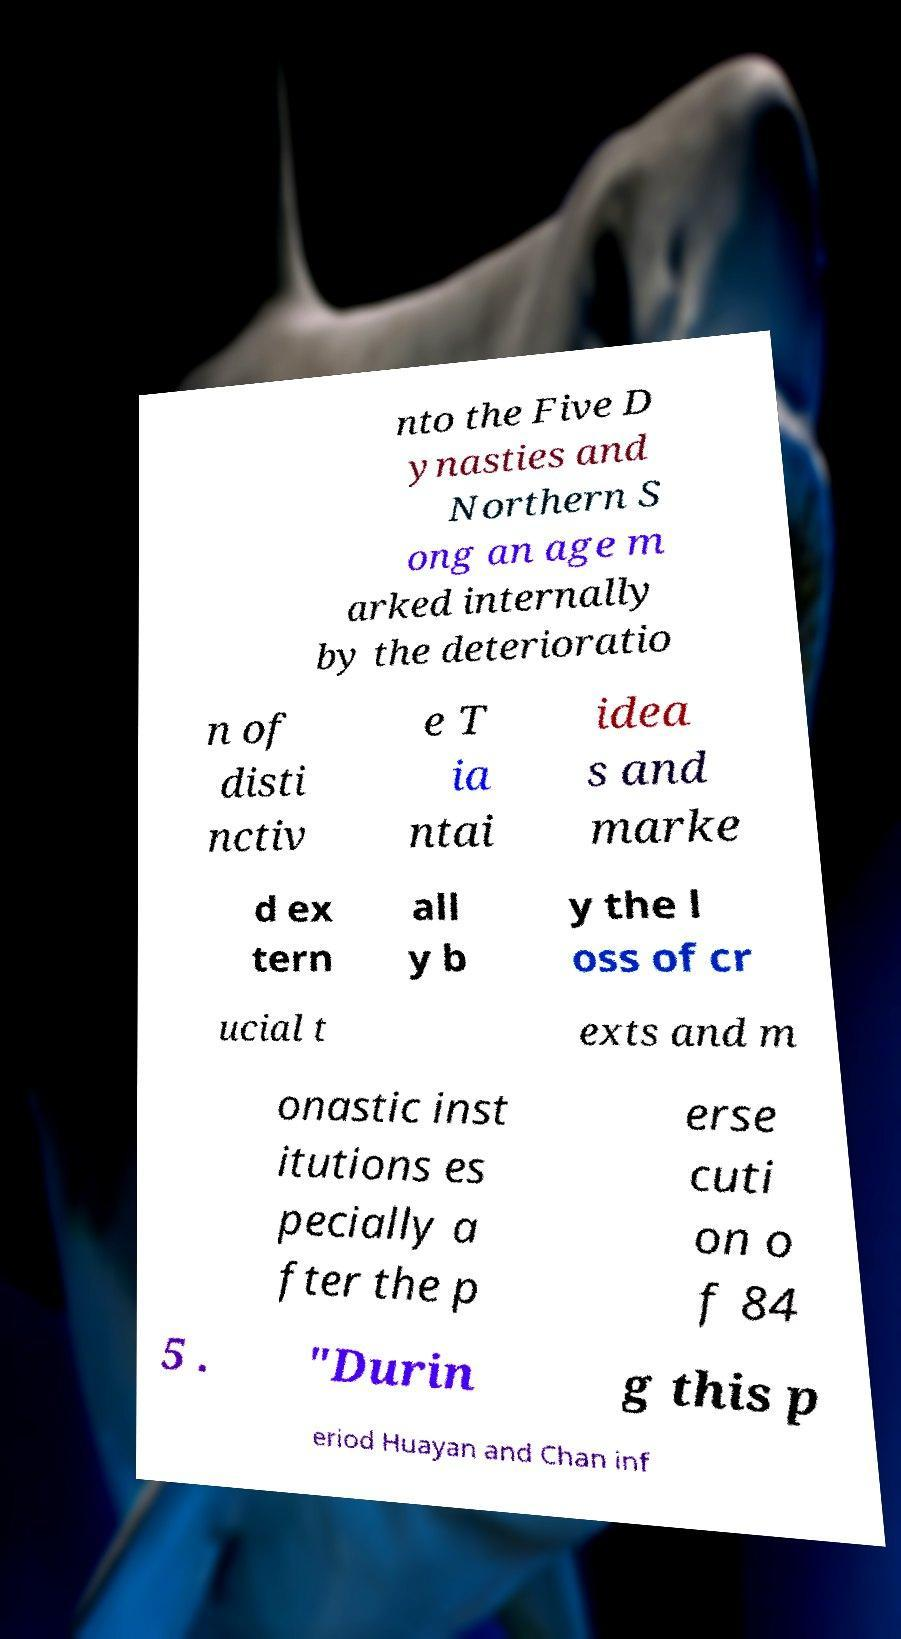Can you accurately transcribe the text from the provided image for me? nto the Five D ynasties and Northern S ong an age m arked internally by the deterioratio n of disti nctiv e T ia ntai idea s and marke d ex tern all y b y the l oss of cr ucial t exts and m onastic inst itutions es pecially a fter the p erse cuti on o f 84 5 . "Durin g this p eriod Huayan and Chan inf 